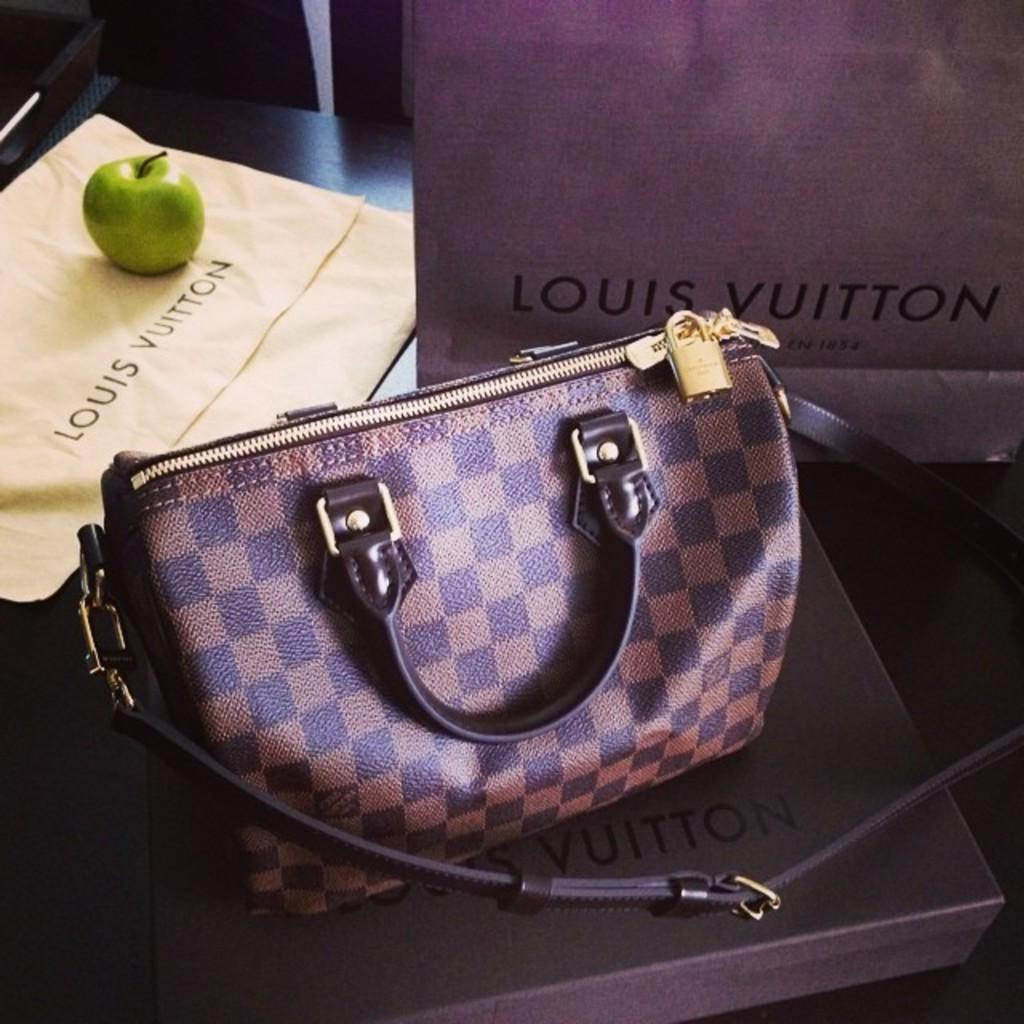What is one of the objects on the table in the image? There is a handbag in the image. What other item can be seen on the table? There is an apple in the image. Where are the handbag and the apple located? Both the handbag and the apple are on a table. Are there any other objects on the table besides the handbag and the apple? Yes, there are other objects on the table. How does the apple rub against the handbag in the image? The apple does not rub against the handbag in the image; they are simply placed on the table next to each other. 